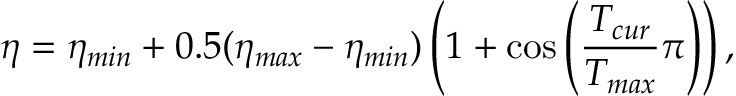Convert formula to latex. <formula><loc_0><loc_0><loc_500><loc_500>\eta = \eta _ { \min } + 0 . 5 ( \eta _ { \max } - \eta _ { \min } ) \left ( 1 + \cos \left ( \frac { T _ { c u r } } { T _ { \max } } \pi \right ) \right ) ,</formula> 